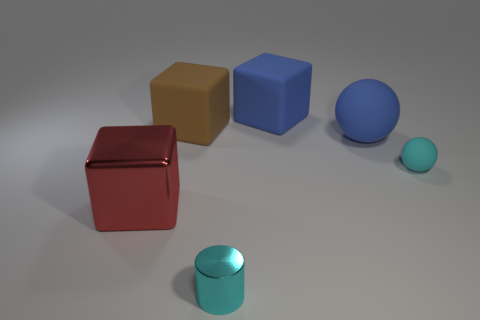Add 2 purple shiny cylinders. How many objects exist? 8 Subtract all matte blocks. How many blocks are left? 1 Subtract all cylinders. How many objects are left? 5 Add 3 yellow metallic things. How many yellow metallic things exist? 3 Subtract 1 cyan spheres. How many objects are left? 5 Subtract all blue metallic things. Subtract all big blue balls. How many objects are left? 5 Add 2 rubber things. How many rubber things are left? 6 